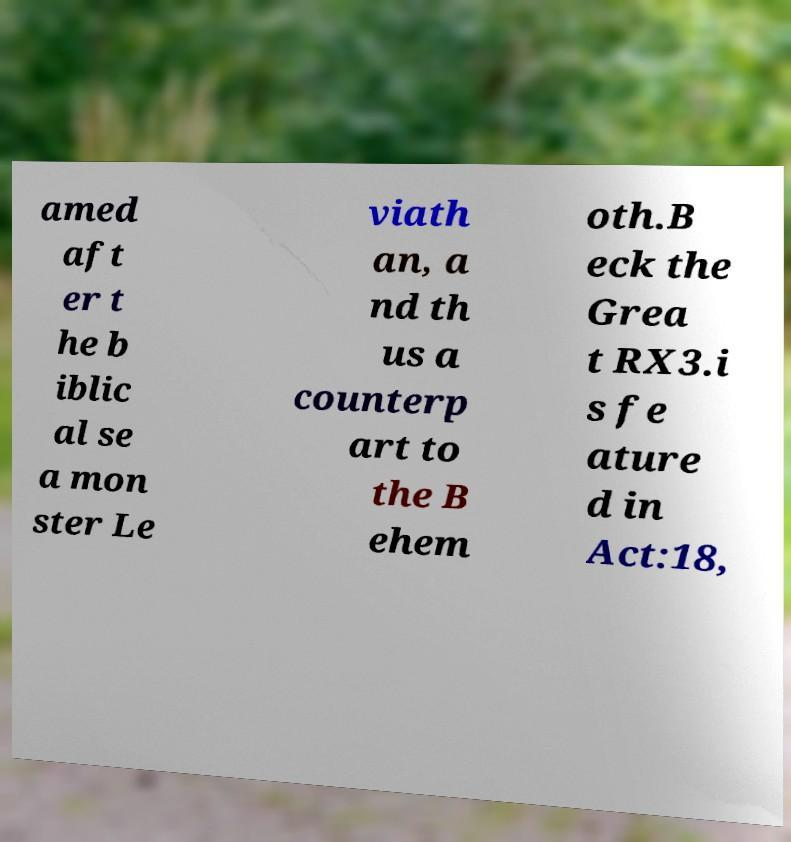Please read and relay the text visible in this image. What does it say? amed aft er t he b iblic al se a mon ster Le viath an, a nd th us a counterp art to the B ehem oth.B eck the Grea t RX3.i s fe ature d in Act:18, 